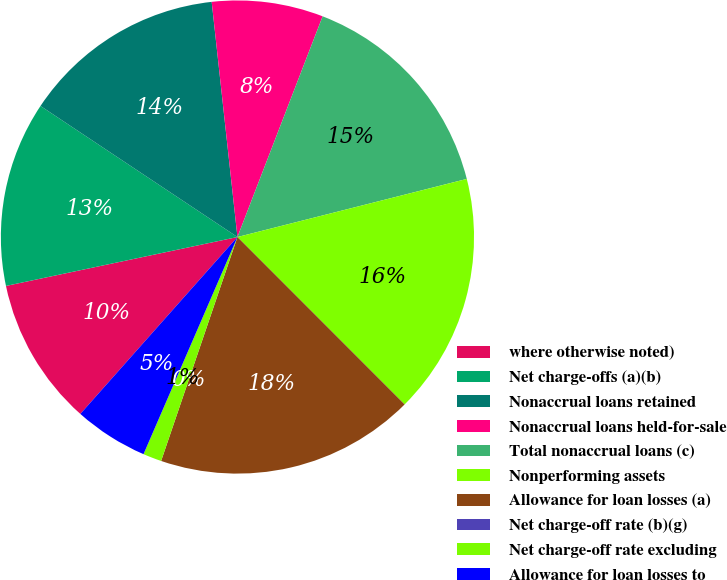Convert chart to OTSL. <chart><loc_0><loc_0><loc_500><loc_500><pie_chart><fcel>where otherwise noted)<fcel>Net charge-offs (a)(b)<fcel>Nonaccrual loans retained<fcel>Nonaccrual loans held-for-sale<fcel>Total nonaccrual loans (c)<fcel>Nonperforming assets<fcel>Allowance for loan losses (a)<fcel>Net charge-off rate (b)(g)<fcel>Net charge-off rate excluding<fcel>Allowance for loan losses to<nl><fcel>10.13%<fcel>12.66%<fcel>13.92%<fcel>7.6%<fcel>15.19%<fcel>16.46%<fcel>17.72%<fcel>0.0%<fcel>1.27%<fcel>5.06%<nl></chart> 